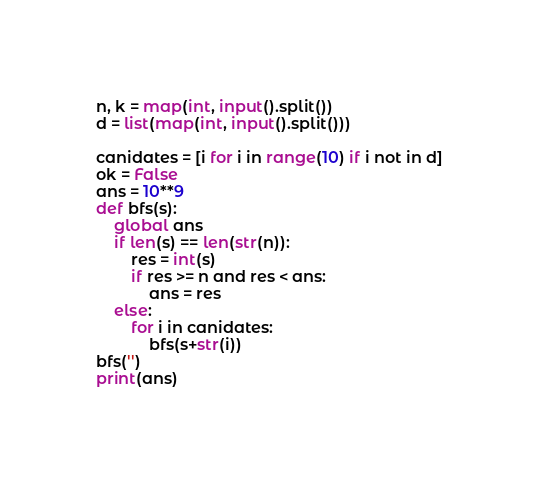<code> <loc_0><loc_0><loc_500><loc_500><_Python_>n, k = map(int, input().split())
d = list(map(int, input().split()))

canidates = [i for i in range(10) if i not in d]
ok = False
ans = 10**9
def bfs(s):
    global ans
    if len(s) == len(str(n)):
        res = int(s)
        if res >= n and res < ans:
            ans = res
    else:
        for i in canidates:
            bfs(s+str(i))
bfs('')
print(ans)

</code> 